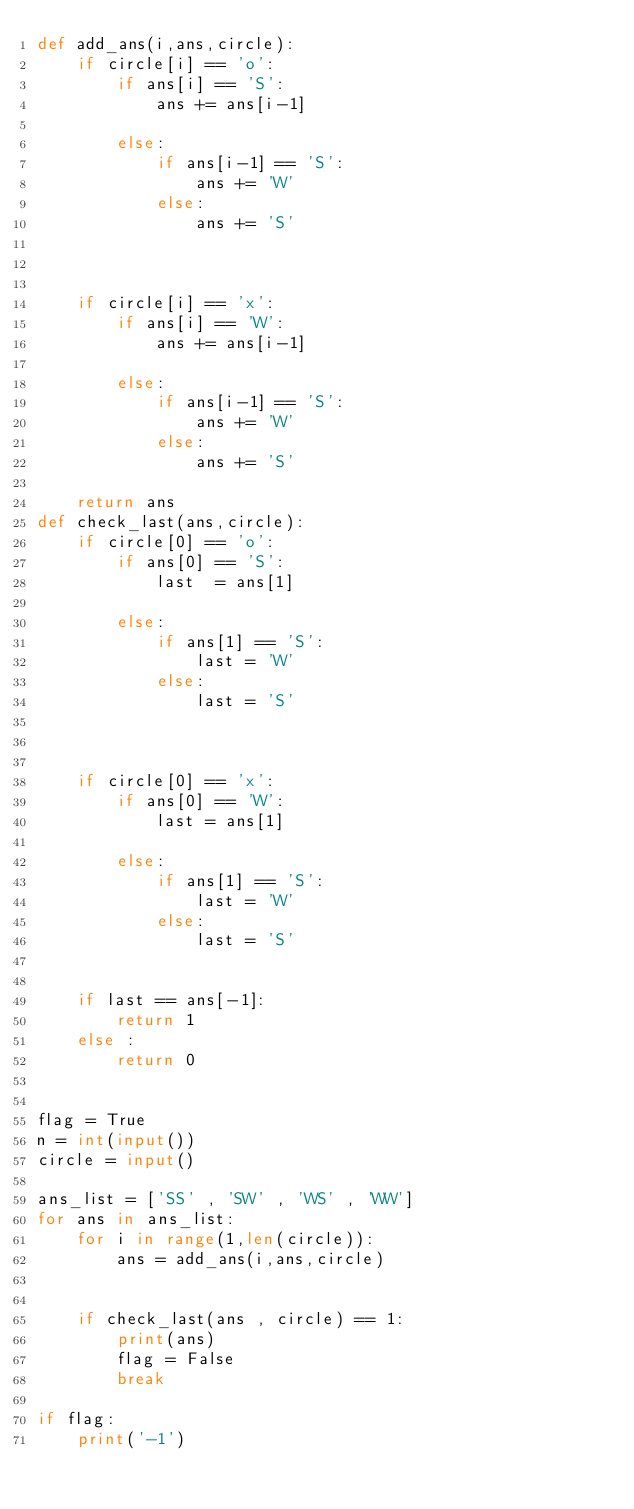<code> <loc_0><loc_0><loc_500><loc_500><_Python_>def add_ans(i,ans,circle):
    if circle[i] == 'o':
        if ans[i] == 'S':
            ans += ans[i-1]

        else:
            if ans[i-1] == 'S':
                ans += 'W'
            else:
                ans += 'S'
            
        
        
    if circle[i] == 'x':
        if ans[i] == 'W':
            ans += ans[i-1]
        
        else:
            if ans[i-1] == 'S':
                ans += 'W'
            else:
                ans += 'S'
            
    return ans
def check_last(ans,circle):
    if circle[0] == 'o':
        if ans[0] == 'S':
            last  = ans[1]

        else:
            if ans[1] == 'S':
                last = 'W'
            else:
                last = 'S'



    if circle[0] == 'x':
        if ans[0] == 'W':
            last = ans[1]

        else:
            if ans[1] == 'S':
                last = 'W'
            else:
                last = 'S'
                
                
    if last == ans[-1]:
        return 1
    else :
        return 0


flag = True
n = int(input())
circle = input()

ans_list = ['SS' , 'SW' , 'WS' , 'WW']
for ans in ans_list:
    for i in range(1,len(circle)):
        ans = add_ans(i,ans,circle)


    if check_last(ans , circle) == 1:
        print(ans)
        flag = False
        break

if flag:
    print('-1')</code> 